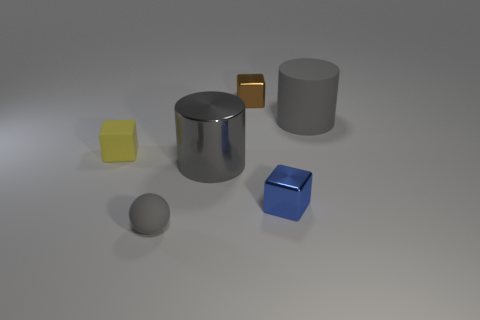Subtract all yellow blocks. How many blocks are left? 2 Add 3 yellow rubber objects. How many objects exist? 9 Subtract all blue blocks. How many blocks are left? 2 Subtract all balls. How many objects are left? 5 Subtract all tiny brown rubber cylinders. Subtract all balls. How many objects are left? 5 Add 3 blue shiny cubes. How many blue shiny cubes are left? 4 Add 4 small purple cylinders. How many small purple cylinders exist? 4 Subtract 0 green cylinders. How many objects are left? 6 Subtract all red cubes. Subtract all green cylinders. How many cubes are left? 3 